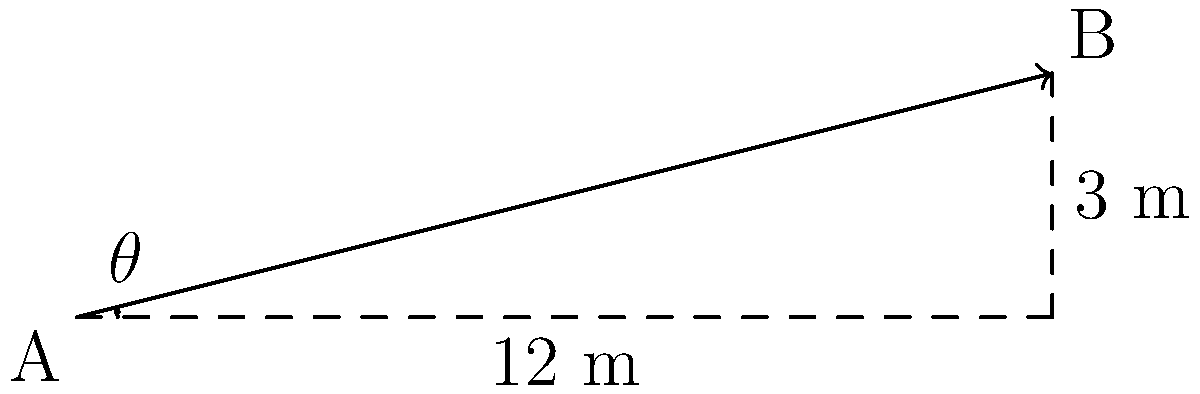As the head of the hospital's ethics committee, you're tasked with reviewing a proposal for a new wheelchair-accessible ramp. The design shows a ramp with a horizontal length of 12 meters and a vertical rise of 3 meters. Using the principles of analytic geometry, calculate the slope of this ramp and determine if it meets the standard maximum slope of 1:12 (rise:run) for wheelchair accessibility. What is the angle of inclination of this ramp in degrees? Let's approach this step-by-step:

1) First, we need to calculate the slope of the ramp. The slope is defined as the ratio of vertical rise to horizontal run.

   Slope = Rise / Run = 3 m / 12 m = 1/4 = 0.25

2) To check if this meets the standard:
   The standard maximum slope is 1:12, which is equivalent to 1/12 ≈ 0.0833

   Since 0.25 > 0.0833, this ramp is steeper than the recommended maximum and does not meet the accessibility standard.

3) To find the angle of inclination, we can use the arctangent function:

   $\theta = \arctan(\text{slope}) = \arctan(0.25)$

4) Converting this to degrees:

   $\theta = \arctan(0.25) \times (180/\pi) \approx 14.04°$

Therefore, the angle of inclination of the ramp is approximately 14.04°.
Answer: 14.04° 